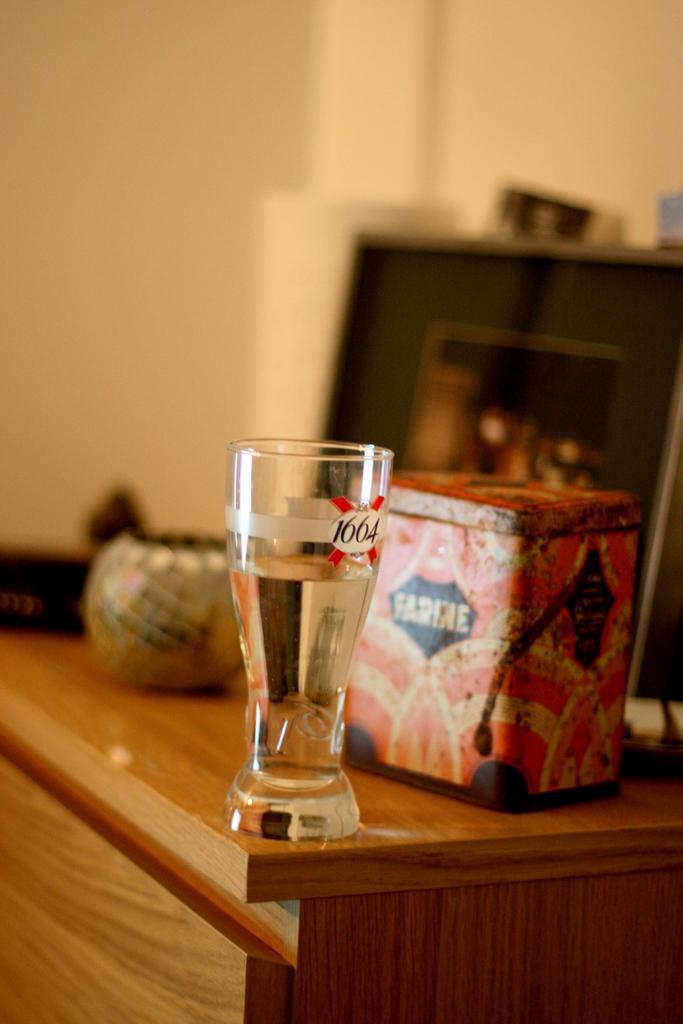How would you summarize this image in a sentence or two? On the background we can see a wall and on the table we can see a box, a glass of water and a pot. 